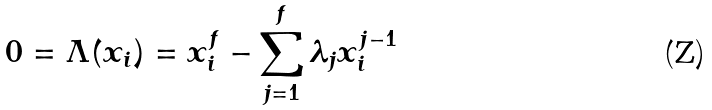<formula> <loc_0><loc_0><loc_500><loc_500>0 = \Lambda ( x _ { i } ) = x _ { i } ^ { f } - \sum _ { j = 1 } ^ { f } \lambda _ { j } x _ { i } ^ { j - 1 }</formula> 